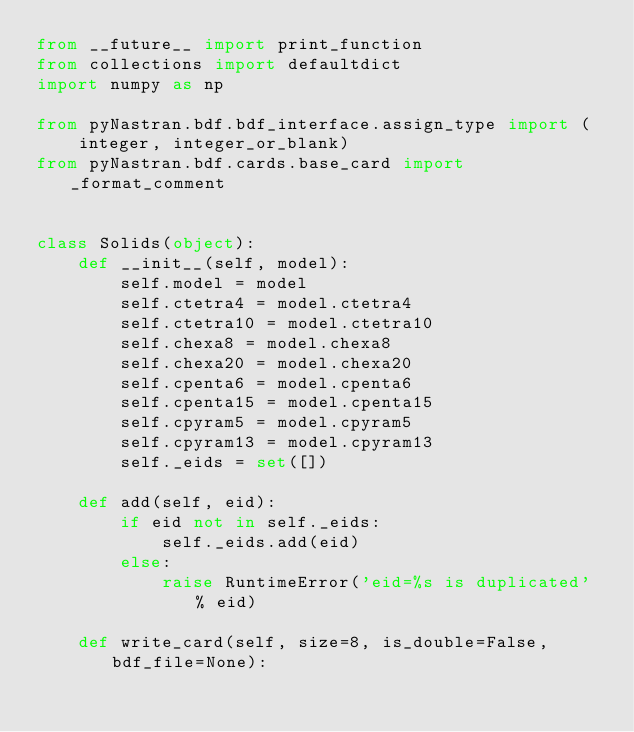<code> <loc_0><loc_0><loc_500><loc_500><_Python_>from __future__ import print_function
from collections import defaultdict
import numpy as np

from pyNastran.bdf.bdf_interface.assign_type import (
    integer, integer_or_blank)
from pyNastran.bdf.cards.base_card import _format_comment


class Solids(object):
    def __init__(self, model):
        self.model = model
        self.ctetra4 = model.ctetra4
        self.ctetra10 = model.ctetra10
        self.chexa8 = model.chexa8
        self.chexa20 = model.chexa20
        self.cpenta6 = model.cpenta6
        self.cpenta15 = model.cpenta15
        self.cpyram5 = model.cpyram5
        self.cpyram13 = model.cpyram13
        self._eids = set([])

    def add(self, eid):
        if eid not in self._eids:
            self._eids.add(eid)
        else:
            raise RuntimeError('eid=%s is duplicated' % eid)

    def write_card(self, size=8, is_double=False, bdf_file=None):</code> 